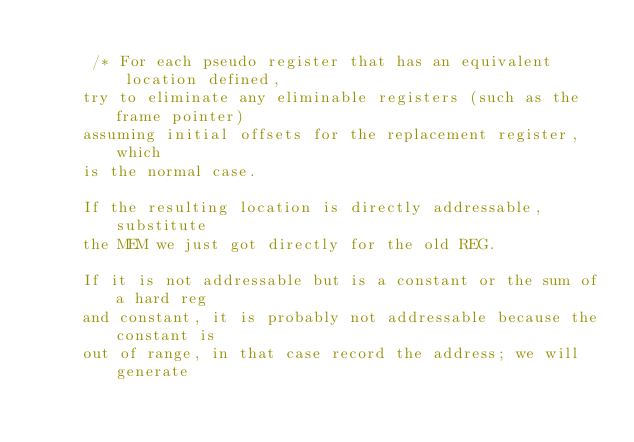Convert code to text. <code><loc_0><loc_0><loc_500><loc_500><_C_>
      /* For each pseudo register that has an equivalent location defined,
	 try to eliminate any eliminable registers (such as the frame pointer)
	 assuming initial offsets for the replacement register, which
	 is the normal case.

	 If the resulting location is directly addressable, substitute
	 the MEM we just got directly for the old REG.

	 If it is not addressable but is a constant or the sum of a hard reg
	 and constant, it is probably not addressable because the constant is
	 out of range, in that case record the address; we will generate</code> 